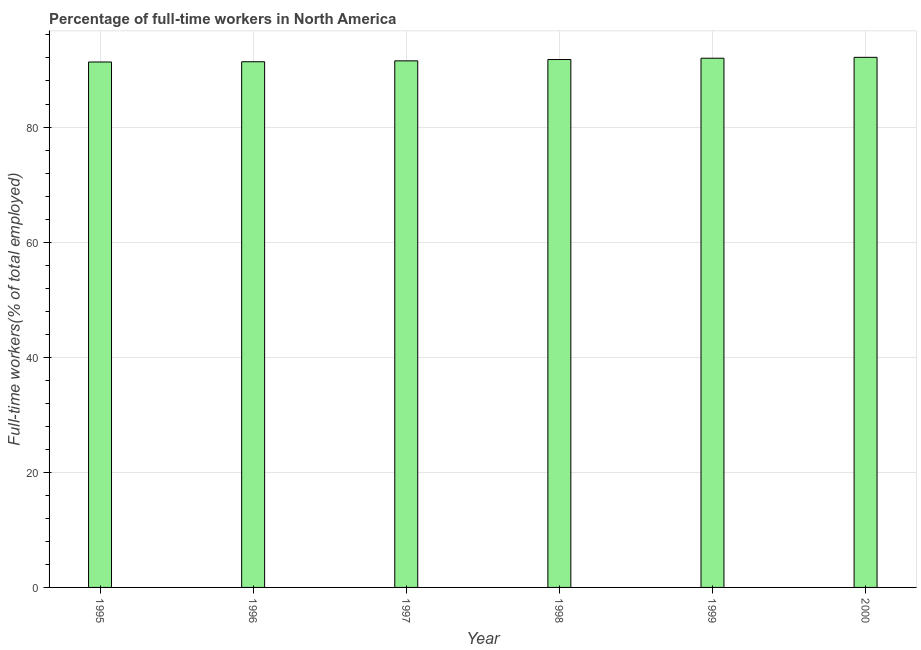Does the graph contain grids?
Keep it short and to the point. Yes. What is the title of the graph?
Offer a very short reply. Percentage of full-time workers in North America. What is the label or title of the X-axis?
Offer a very short reply. Year. What is the label or title of the Y-axis?
Your answer should be compact. Full-time workers(% of total employed). What is the percentage of full-time workers in 1999?
Offer a terse response. 91.96. Across all years, what is the maximum percentage of full-time workers?
Provide a short and direct response. 92.11. Across all years, what is the minimum percentage of full-time workers?
Offer a terse response. 91.3. In which year was the percentage of full-time workers maximum?
Keep it short and to the point. 2000. What is the sum of the percentage of full-time workers?
Offer a terse response. 549.93. What is the difference between the percentage of full-time workers in 1995 and 1996?
Offer a very short reply. -0.04. What is the average percentage of full-time workers per year?
Keep it short and to the point. 91.66. What is the median percentage of full-time workers?
Your answer should be compact. 91.61. In how many years, is the percentage of full-time workers greater than 84 %?
Offer a very short reply. 6. Do a majority of the years between 1995 and 1996 (inclusive) have percentage of full-time workers greater than 88 %?
Your answer should be very brief. Yes. What is the ratio of the percentage of full-time workers in 1995 to that in 1996?
Provide a short and direct response. 1. What is the difference between the highest and the second highest percentage of full-time workers?
Keep it short and to the point. 0.15. What is the difference between the highest and the lowest percentage of full-time workers?
Your response must be concise. 0.81. In how many years, is the percentage of full-time workers greater than the average percentage of full-time workers taken over all years?
Make the answer very short. 3. How many bars are there?
Provide a short and direct response. 6. Are all the bars in the graph horizontal?
Your answer should be very brief. No. What is the difference between two consecutive major ticks on the Y-axis?
Give a very brief answer. 20. Are the values on the major ticks of Y-axis written in scientific E-notation?
Keep it short and to the point. No. What is the Full-time workers(% of total employed) of 1995?
Provide a succinct answer. 91.3. What is the Full-time workers(% of total employed) in 1996?
Make the answer very short. 91.34. What is the Full-time workers(% of total employed) in 1997?
Ensure brevity in your answer.  91.5. What is the Full-time workers(% of total employed) in 1998?
Offer a very short reply. 91.73. What is the Full-time workers(% of total employed) in 1999?
Your answer should be compact. 91.96. What is the Full-time workers(% of total employed) of 2000?
Make the answer very short. 92.11. What is the difference between the Full-time workers(% of total employed) in 1995 and 1996?
Provide a short and direct response. -0.04. What is the difference between the Full-time workers(% of total employed) in 1995 and 1997?
Your response must be concise. -0.2. What is the difference between the Full-time workers(% of total employed) in 1995 and 1998?
Provide a short and direct response. -0.43. What is the difference between the Full-time workers(% of total employed) in 1995 and 1999?
Offer a very short reply. -0.66. What is the difference between the Full-time workers(% of total employed) in 1995 and 2000?
Keep it short and to the point. -0.81. What is the difference between the Full-time workers(% of total employed) in 1996 and 1997?
Provide a succinct answer. -0.15. What is the difference between the Full-time workers(% of total employed) in 1996 and 1998?
Give a very brief answer. -0.38. What is the difference between the Full-time workers(% of total employed) in 1996 and 1999?
Ensure brevity in your answer.  -0.61. What is the difference between the Full-time workers(% of total employed) in 1996 and 2000?
Keep it short and to the point. -0.77. What is the difference between the Full-time workers(% of total employed) in 1997 and 1998?
Keep it short and to the point. -0.23. What is the difference between the Full-time workers(% of total employed) in 1997 and 1999?
Your response must be concise. -0.46. What is the difference between the Full-time workers(% of total employed) in 1997 and 2000?
Keep it short and to the point. -0.61. What is the difference between the Full-time workers(% of total employed) in 1998 and 1999?
Your answer should be very brief. -0.23. What is the difference between the Full-time workers(% of total employed) in 1998 and 2000?
Keep it short and to the point. -0.38. What is the difference between the Full-time workers(% of total employed) in 1999 and 2000?
Your response must be concise. -0.15. What is the ratio of the Full-time workers(% of total employed) in 1995 to that in 1996?
Offer a very short reply. 1. What is the ratio of the Full-time workers(% of total employed) in 1995 to that in 1997?
Keep it short and to the point. 1. What is the ratio of the Full-time workers(% of total employed) in 1995 to that in 1998?
Your answer should be very brief. 0.99. What is the ratio of the Full-time workers(% of total employed) in 1995 to that in 2000?
Offer a terse response. 0.99. What is the ratio of the Full-time workers(% of total employed) in 1996 to that in 1997?
Offer a very short reply. 1. What is the ratio of the Full-time workers(% of total employed) in 1996 to that in 1999?
Your answer should be very brief. 0.99. What is the ratio of the Full-time workers(% of total employed) in 1996 to that in 2000?
Make the answer very short. 0.99. What is the ratio of the Full-time workers(% of total employed) in 1997 to that in 1999?
Provide a succinct answer. 0.99. What is the ratio of the Full-time workers(% of total employed) in 1998 to that in 2000?
Provide a succinct answer. 1. 